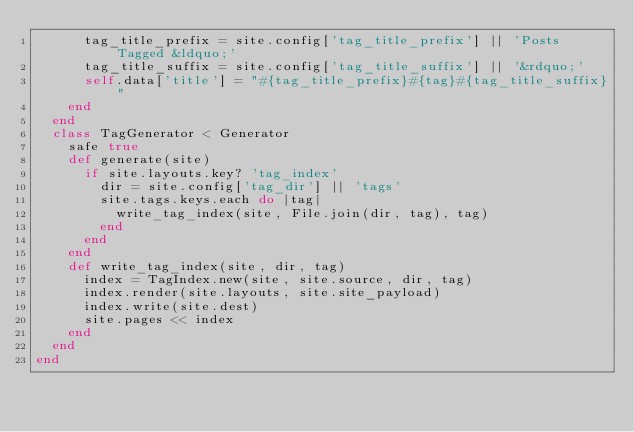<code> <loc_0><loc_0><loc_500><loc_500><_Ruby_>      tag_title_prefix = site.config['tag_title_prefix'] || 'Posts Tagged &ldquo;'
      tag_title_suffix = site.config['tag_title_suffix'] || '&rdquo;'
      self.data['title'] = "#{tag_title_prefix}#{tag}#{tag_title_suffix}"
    end
  end
  class TagGenerator < Generator
    safe true
    def generate(site)
      if site.layouts.key? 'tag_index'
        dir = site.config['tag_dir'] || 'tags'
        site.tags.keys.each do |tag|
          write_tag_index(site, File.join(dir, tag), tag)
        end
      end
    end
    def write_tag_index(site, dir, tag)
      index = TagIndex.new(site, site.source, dir, tag)
      index.render(site.layouts, site.site_payload)
      index.write(site.dest)
      site.pages << index
    end
  end
end</code> 